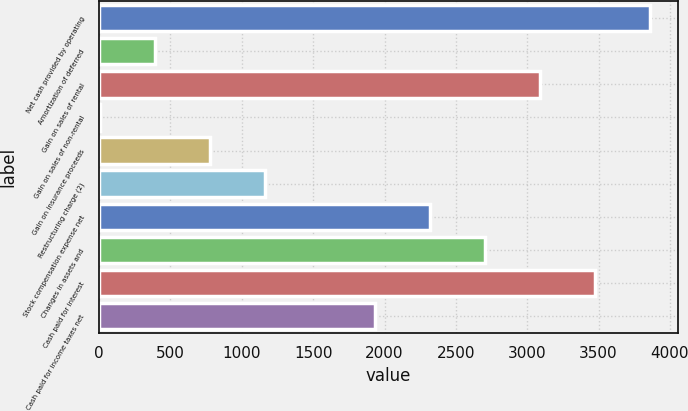<chart> <loc_0><loc_0><loc_500><loc_500><bar_chart><fcel>Net cash provided by operating<fcel>Amortization of deferred<fcel>Gain on sales of rental<fcel>Gain on sales of non-rental<fcel>Gain on insurance proceeds<fcel>Restructuring charge (2)<fcel>Stock compensation expense net<fcel>Changes in assets and<fcel>Cash paid for interest<fcel>Cash paid for income taxes net<nl><fcel>3863<fcel>391.7<fcel>3091.6<fcel>6<fcel>777.4<fcel>1163.1<fcel>2320.2<fcel>2705.9<fcel>3477.3<fcel>1934.5<nl></chart> 